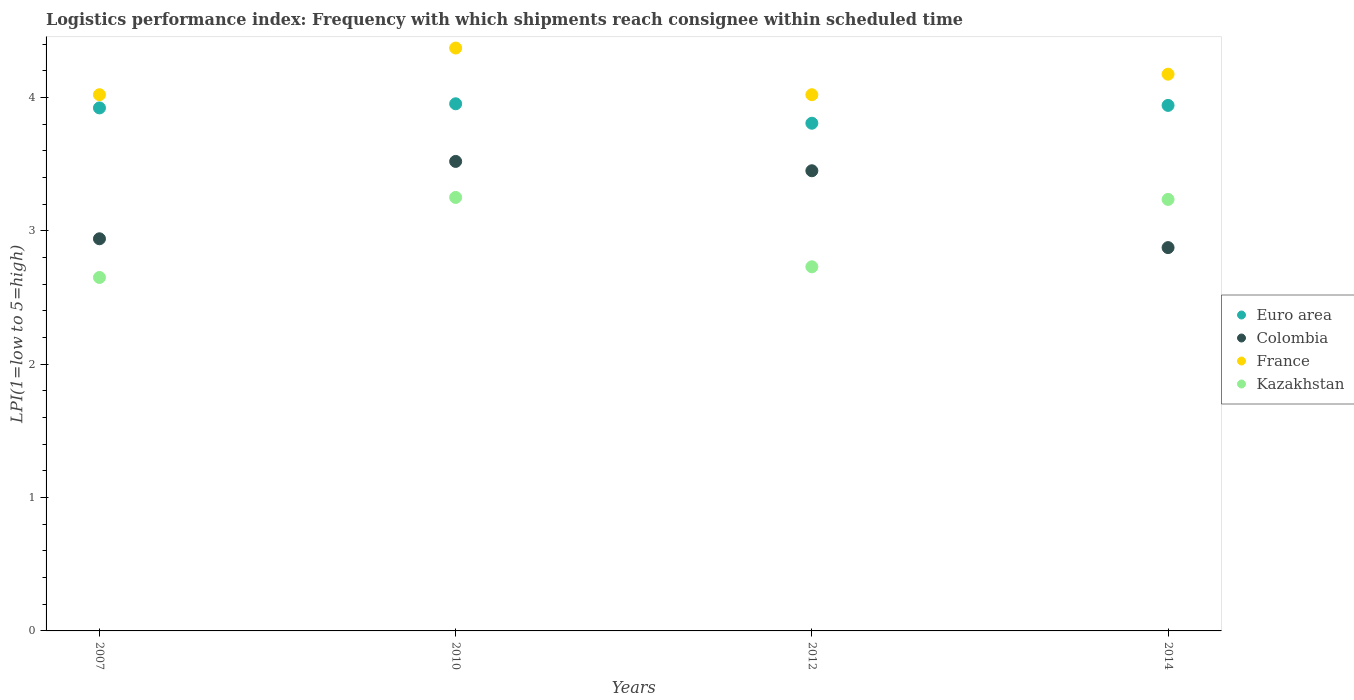What is the logistics performance index in Colombia in 2012?
Provide a short and direct response. 3.45. Across all years, what is the maximum logistics performance index in France?
Your response must be concise. 4.37. Across all years, what is the minimum logistics performance index in Kazakhstan?
Your response must be concise. 2.65. In which year was the logistics performance index in Euro area minimum?
Your answer should be compact. 2012. What is the total logistics performance index in France in the graph?
Keep it short and to the point. 16.58. What is the difference between the logistics performance index in Colombia in 2010 and that in 2014?
Keep it short and to the point. 0.65. What is the difference between the logistics performance index in Colombia in 2012 and the logistics performance index in Kazakhstan in 2010?
Your answer should be very brief. 0.2. What is the average logistics performance index in Euro area per year?
Offer a terse response. 3.9. In the year 2014, what is the difference between the logistics performance index in France and logistics performance index in Kazakhstan?
Provide a short and direct response. 0.94. In how many years, is the logistics performance index in Kazakhstan greater than 1.8?
Provide a short and direct response. 4. What is the ratio of the logistics performance index in Kazakhstan in 2007 to that in 2014?
Ensure brevity in your answer.  0.82. Is the logistics performance index in Colombia in 2012 less than that in 2014?
Keep it short and to the point. No. What is the difference between the highest and the second highest logistics performance index in Colombia?
Provide a short and direct response. 0.07. What is the difference between the highest and the lowest logistics performance index in France?
Offer a very short reply. 0.35. In how many years, is the logistics performance index in Colombia greater than the average logistics performance index in Colombia taken over all years?
Offer a terse response. 2. Is it the case that in every year, the sum of the logistics performance index in Euro area and logistics performance index in Kazakhstan  is greater than the sum of logistics performance index in France and logistics performance index in Colombia?
Provide a succinct answer. Yes. Is it the case that in every year, the sum of the logistics performance index in Kazakhstan and logistics performance index in France  is greater than the logistics performance index in Euro area?
Provide a succinct answer. Yes. Does the logistics performance index in Colombia monotonically increase over the years?
Provide a short and direct response. No. Is the logistics performance index in France strictly greater than the logistics performance index in Euro area over the years?
Give a very brief answer. Yes. Is the logistics performance index in Colombia strictly less than the logistics performance index in France over the years?
Offer a very short reply. Yes. How many dotlines are there?
Give a very brief answer. 4. What is the difference between two consecutive major ticks on the Y-axis?
Your answer should be very brief. 1. Does the graph contain grids?
Offer a terse response. No. What is the title of the graph?
Make the answer very short. Logistics performance index: Frequency with which shipments reach consignee within scheduled time. What is the label or title of the X-axis?
Your answer should be compact. Years. What is the label or title of the Y-axis?
Offer a very short reply. LPI(1=low to 5=high). What is the LPI(1=low to 5=high) of Euro area in 2007?
Your answer should be very brief. 3.92. What is the LPI(1=low to 5=high) in Colombia in 2007?
Provide a succinct answer. 2.94. What is the LPI(1=low to 5=high) in France in 2007?
Provide a short and direct response. 4.02. What is the LPI(1=low to 5=high) of Kazakhstan in 2007?
Your answer should be very brief. 2.65. What is the LPI(1=low to 5=high) of Euro area in 2010?
Provide a short and direct response. 3.95. What is the LPI(1=low to 5=high) of Colombia in 2010?
Your response must be concise. 3.52. What is the LPI(1=low to 5=high) of France in 2010?
Your response must be concise. 4.37. What is the LPI(1=low to 5=high) of Euro area in 2012?
Provide a succinct answer. 3.81. What is the LPI(1=low to 5=high) of Colombia in 2012?
Ensure brevity in your answer.  3.45. What is the LPI(1=low to 5=high) in France in 2012?
Your answer should be very brief. 4.02. What is the LPI(1=low to 5=high) of Kazakhstan in 2012?
Make the answer very short. 2.73. What is the LPI(1=low to 5=high) in Euro area in 2014?
Ensure brevity in your answer.  3.94. What is the LPI(1=low to 5=high) in Colombia in 2014?
Give a very brief answer. 2.87. What is the LPI(1=low to 5=high) in France in 2014?
Your answer should be very brief. 4.17. What is the LPI(1=low to 5=high) of Kazakhstan in 2014?
Your answer should be very brief. 3.24. Across all years, what is the maximum LPI(1=low to 5=high) in Euro area?
Keep it short and to the point. 3.95. Across all years, what is the maximum LPI(1=low to 5=high) in Colombia?
Ensure brevity in your answer.  3.52. Across all years, what is the maximum LPI(1=low to 5=high) of France?
Provide a short and direct response. 4.37. Across all years, what is the minimum LPI(1=low to 5=high) in Euro area?
Provide a short and direct response. 3.81. Across all years, what is the minimum LPI(1=low to 5=high) in Colombia?
Offer a very short reply. 2.87. Across all years, what is the minimum LPI(1=low to 5=high) of France?
Keep it short and to the point. 4.02. Across all years, what is the minimum LPI(1=low to 5=high) in Kazakhstan?
Give a very brief answer. 2.65. What is the total LPI(1=low to 5=high) of Euro area in the graph?
Keep it short and to the point. 15.62. What is the total LPI(1=low to 5=high) of Colombia in the graph?
Your answer should be compact. 12.78. What is the total LPI(1=low to 5=high) of France in the graph?
Give a very brief answer. 16.58. What is the total LPI(1=low to 5=high) of Kazakhstan in the graph?
Offer a very short reply. 11.87. What is the difference between the LPI(1=low to 5=high) of Euro area in 2007 and that in 2010?
Make the answer very short. -0.03. What is the difference between the LPI(1=low to 5=high) of Colombia in 2007 and that in 2010?
Offer a very short reply. -0.58. What is the difference between the LPI(1=low to 5=high) in France in 2007 and that in 2010?
Your answer should be very brief. -0.35. What is the difference between the LPI(1=low to 5=high) of Kazakhstan in 2007 and that in 2010?
Your response must be concise. -0.6. What is the difference between the LPI(1=low to 5=high) of Euro area in 2007 and that in 2012?
Your response must be concise. 0.11. What is the difference between the LPI(1=low to 5=high) of Colombia in 2007 and that in 2012?
Ensure brevity in your answer.  -0.51. What is the difference between the LPI(1=low to 5=high) in Kazakhstan in 2007 and that in 2012?
Ensure brevity in your answer.  -0.08. What is the difference between the LPI(1=low to 5=high) in Euro area in 2007 and that in 2014?
Your answer should be compact. -0.02. What is the difference between the LPI(1=low to 5=high) of Colombia in 2007 and that in 2014?
Provide a succinct answer. 0.07. What is the difference between the LPI(1=low to 5=high) in France in 2007 and that in 2014?
Your answer should be very brief. -0.15. What is the difference between the LPI(1=low to 5=high) of Kazakhstan in 2007 and that in 2014?
Your answer should be very brief. -0.59. What is the difference between the LPI(1=low to 5=high) of Euro area in 2010 and that in 2012?
Offer a terse response. 0.15. What is the difference between the LPI(1=low to 5=high) of Colombia in 2010 and that in 2012?
Provide a succinct answer. 0.07. What is the difference between the LPI(1=low to 5=high) in France in 2010 and that in 2012?
Give a very brief answer. 0.35. What is the difference between the LPI(1=low to 5=high) in Kazakhstan in 2010 and that in 2012?
Your answer should be very brief. 0.52. What is the difference between the LPI(1=low to 5=high) of Euro area in 2010 and that in 2014?
Offer a very short reply. 0.01. What is the difference between the LPI(1=low to 5=high) in Colombia in 2010 and that in 2014?
Your answer should be very brief. 0.65. What is the difference between the LPI(1=low to 5=high) in France in 2010 and that in 2014?
Give a very brief answer. 0.2. What is the difference between the LPI(1=low to 5=high) of Kazakhstan in 2010 and that in 2014?
Your answer should be very brief. 0.01. What is the difference between the LPI(1=low to 5=high) of Euro area in 2012 and that in 2014?
Ensure brevity in your answer.  -0.13. What is the difference between the LPI(1=low to 5=high) in Colombia in 2012 and that in 2014?
Keep it short and to the point. 0.58. What is the difference between the LPI(1=low to 5=high) of France in 2012 and that in 2014?
Provide a short and direct response. -0.15. What is the difference between the LPI(1=low to 5=high) in Kazakhstan in 2012 and that in 2014?
Offer a terse response. -0.51. What is the difference between the LPI(1=low to 5=high) in Euro area in 2007 and the LPI(1=low to 5=high) in Colombia in 2010?
Offer a terse response. 0.4. What is the difference between the LPI(1=low to 5=high) of Euro area in 2007 and the LPI(1=low to 5=high) of France in 2010?
Offer a very short reply. -0.45. What is the difference between the LPI(1=low to 5=high) in Euro area in 2007 and the LPI(1=low to 5=high) in Kazakhstan in 2010?
Make the answer very short. 0.67. What is the difference between the LPI(1=low to 5=high) in Colombia in 2007 and the LPI(1=low to 5=high) in France in 2010?
Keep it short and to the point. -1.43. What is the difference between the LPI(1=low to 5=high) in Colombia in 2007 and the LPI(1=low to 5=high) in Kazakhstan in 2010?
Provide a succinct answer. -0.31. What is the difference between the LPI(1=low to 5=high) in France in 2007 and the LPI(1=low to 5=high) in Kazakhstan in 2010?
Your answer should be very brief. 0.77. What is the difference between the LPI(1=low to 5=high) in Euro area in 2007 and the LPI(1=low to 5=high) in Colombia in 2012?
Offer a very short reply. 0.47. What is the difference between the LPI(1=low to 5=high) of Euro area in 2007 and the LPI(1=low to 5=high) of France in 2012?
Ensure brevity in your answer.  -0.1. What is the difference between the LPI(1=low to 5=high) of Euro area in 2007 and the LPI(1=low to 5=high) of Kazakhstan in 2012?
Ensure brevity in your answer.  1.19. What is the difference between the LPI(1=low to 5=high) in Colombia in 2007 and the LPI(1=low to 5=high) in France in 2012?
Your answer should be very brief. -1.08. What is the difference between the LPI(1=low to 5=high) in Colombia in 2007 and the LPI(1=low to 5=high) in Kazakhstan in 2012?
Your answer should be compact. 0.21. What is the difference between the LPI(1=low to 5=high) of France in 2007 and the LPI(1=low to 5=high) of Kazakhstan in 2012?
Your response must be concise. 1.29. What is the difference between the LPI(1=low to 5=high) in Euro area in 2007 and the LPI(1=low to 5=high) in Colombia in 2014?
Your answer should be very brief. 1.05. What is the difference between the LPI(1=low to 5=high) in Euro area in 2007 and the LPI(1=low to 5=high) in France in 2014?
Your response must be concise. -0.25. What is the difference between the LPI(1=low to 5=high) in Euro area in 2007 and the LPI(1=low to 5=high) in Kazakhstan in 2014?
Ensure brevity in your answer.  0.69. What is the difference between the LPI(1=low to 5=high) of Colombia in 2007 and the LPI(1=low to 5=high) of France in 2014?
Your answer should be compact. -1.23. What is the difference between the LPI(1=low to 5=high) of Colombia in 2007 and the LPI(1=low to 5=high) of Kazakhstan in 2014?
Your answer should be very brief. -0.3. What is the difference between the LPI(1=low to 5=high) in France in 2007 and the LPI(1=low to 5=high) in Kazakhstan in 2014?
Make the answer very short. 0.78. What is the difference between the LPI(1=low to 5=high) in Euro area in 2010 and the LPI(1=low to 5=high) in Colombia in 2012?
Ensure brevity in your answer.  0.5. What is the difference between the LPI(1=low to 5=high) in Euro area in 2010 and the LPI(1=low to 5=high) in France in 2012?
Your answer should be very brief. -0.07. What is the difference between the LPI(1=low to 5=high) of Euro area in 2010 and the LPI(1=low to 5=high) of Kazakhstan in 2012?
Your answer should be very brief. 1.22. What is the difference between the LPI(1=low to 5=high) in Colombia in 2010 and the LPI(1=low to 5=high) in France in 2012?
Give a very brief answer. -0.5. What is the difference between the LPI(1=low to 5=high) in Colombia in 2010 and the LPI(1=low to 5=high) in Kazakhstan in 2012?
Offer a very short reply. 0.79. What is the difference between the LPI(1=low to 5=high) in France in 2010 and the LPI(1=low to 5=high) in Kazakhstan in 2012?
Your answer should be very brief. 1.64. What is the difference between the LPI(1=low to 5=high) of Euro area in 2010 and the LPI(1=low to 5=high) of Colombia in 2014?
Offer a terse response. 1.08. What is the difference between the LPI(1=low to 5=high) in Euro area in 2010 and the LPI(1=low to 5=high) in France in 2014?
Make the answer very short. -0.22. What is the difference between the LPI(1=low to 5=high) in Euro area in 2010 and the LPI(1=low to 5=high) in Kazakhstan in 2014?
Make the answer very short. 0.72. What is the difference between the LPI(1=low to 5=high) in Colombia in 2010 and the LPI(1=low to 5=high) in France in 2014?
Provide a succinct answer. -0.65. What is the difference between the LPI(1=low to 5=high) in Colombia in 2010 and the LPI(1=low to 5=high) in Kazakhstan in 2014?
Your response must be concise. 0.28. What is the difference between the LPI(1=low to 5=high) of France in 2010 and the LPI(1=low to 5=high) of Kazakhstan in 2014?
Keep it short and to the point. 1.13. What is the difference between the LPI(1=low to 5=high) of Euro area in 2012 and the LPI(1=low to 5=high) of Colombia in 2014?
Your answer should be compact. 0.93. What is the difference between the LPI(1=low to 5=high) in Euro area in 2012 and the LPI(1=low to 5=high) in France in 2014?
Your answer should be very brief. -0.37. What is the difference between the LPI(1=low to 5=high) in Euro area in 2012 and the LPI(1=low to 5=high) in Kazakhstan in 2014?
Make the answer very short. 0.57. What is the difference between the LPI(1=low to 5=high) of Colombia in 2012 and the LPI(1=low to 5=high) of France in 2014?
Keep it short and to the point. -0.72. What is the difference between the LPI(1=low to 5=high) in Colombia in 2012 and the LPI(1=low to 5=high) in Kazakhstan in 2014?
Ensure brevity in your answer.  0.21. What is the difference between the LPI(1=low to 5=high) of France in 2012 and the LPI(1=low to 5=high) of Kazakhstan in 2014?
Offer a very short reply. 0.78. What is the average LPI(1=low to 5=high) in Euro area per year?
Ensure brevity in your answer.  3.9. What is the average LPI(1=low to 5=high) in Colombia per year?
Give a very brief answer. 3.2. What is the average LPI(1=low to 5=high) of France per year?
Your response must be concise. 4.15. What is the average LPI(1=low to 5=high) in Kazakhstan per year?
Provide a short and direct response. 2.97. In the year 2007, what is the difference between the LPI(1=low to 5=high) in Euro area and LPI(1=low to 5=high) in Colombia?
Keep it short and to the point. 0.98. In the year 2007, what is the difference between the LPI(1=low to 5=high) in Euro area and LPI(1=low to 5=high) in France?
Offer a terse response. -0.1. In the year 2007, what is the difference between the LPI(1=low to 5=high) in Euro area and LPI(1=low to 5=high) in Kazakhstan?
Your response must be concise. 1.27. In the year 2007, what is the difference between the LPI(1=low to 5=high) in Colombia and LPI(1=low to 5=high) in France?
Make the answer very short. -1.08. In the year 2007, what is the difference between the LPI(1=low to 5=high) of Colombia and LPI(1=low to 5=high) of Kazakhstan?
Offer a very short reply. 0.29. In the year 2007, what is the difference between the LPI(1=low to 5=high) in France and LPI(1=low to 5=high) in Kazakhstan?
Ensure brevity in your answer.  1.37. In the year 2010, what is the difference between the LPI(1=low to 5=high) in Euro area and LPI(1=low to 5=high) in Colombia?
Keep it short and to the point. 0.43. In the year 2010, what is the difference between the LPI(1=low to 5=high) in Euro area and LPI(1=low to 5=high) in France?
Provide a succinct answer. -0.42. In the year 2010, what is the difference between the LPI(1=low to 5=high) in Euro area and LPI(1=low to 5=high) in Kazakhstan?
Ensure brevity in your answer.  0.7. In the year 2010, what is the difference between the LPI(1=low to 5=high) in Colombia and LPI(1=low to 5=high) in France?
Give a very brief answer. -0.85. In the year 2010, what is the difference between the LPI(1=low to 5=high) in Colombia and LPI(1=low to 5=high) in Kazakhstan?
Your response must be concise. 0.27. In the year 2010, what is the difference between the LPI(1=low to 5=high) in France and LPI(1=low to 5=high) in Kazakhstan?
Offer a terse response. 1.12. In the year 2012, what is the difference between the LPI(1=low to 5=high) of Euro area and LPI(1=low to 5=high) of Colombia?
Provide a short and direct response. 0.36. In the year 2012, what is the difference between the LPI(1=low to 5=high) of Euro area and LPI(1=low to 5=high) of France?
Your response must be concise. -0.21. In the year 2012, what is the difference between the LPI(1=low to 5=high) in Euro area and LPI(1=low to 5=high) in Kazakhstan?
Offer a very short reply. 1.08. In the year 2012, what is the difference between the LPI(1=low to 5=high) of Colombia and LPI(1=low to 5=high) of France?
Your answer should be very brief. -0.57. In the year 2012, what is the difference between the LPI(1=low to 5=high) in Colombia and LPI(1=low to 5=high) in Kazakhstan?
Your answer should be very brief. 0.72. In the year 2012, what is the difference between the LPI(1=low to 5=high) of France and LPI(1=low to 5=high) of Kazakhstan?
Offer a very short reply. 1.29. In the year 2014, what is the difference between the LPI(1=low to 5=high) of Euro area and LPI(1=low to 5=high) of Colombia?
Give a very brief answer. 1.07. In the year 2014, what is the difference between the LPI(1=low to 5=high) of Euro area and LPI(1=low to 5=high) of France?
Offer a terse response. -0.23. In the year 2014, what is the difference between the LPI(1=low to 5=high) in Euro area and LPI(1=low to 5=high) in Kazakhstan?
Provide a short and direct response. 0.7. In the year 2014, what is the difference between the LPI(1=low to 5=high) of Colombia and LPI(1=low to 5=high) of France?
Ensure brevity in your answer.  -1.3. In the year 2014, what is the difference between the LPI(1=low to 5=high) in Colombia and LPI(1=low to 5=high) in Kazakhstan?
Give a very brief answer. -0.36. In the year 2014, what is the difference between the LPI(1=low to 5=high) of France and LPI(1=low to 5=high) of Kazakhstan?
Ensure brevity in your answer.  0.94. What is the ratio of the LPI(1=low to 5=high) of Euro area in 2007 to that in 2010?
Offer a very short reply. 0.99. What is the ratio of the LPI(1=low to 5=high) of Colombia in 2007 to that in 2010?
Your answer should be very brief. 0.84. What is the ratio of the LPI(1=low to 5=high) in France in 2007 to that in 2010?
Your response must be concise. 0.92. What is the ratio of the LPI(1=low to 5=high) of Kazakhstan in 2007 to that in 2010?
Make the answer very short. 0.82. What is the ratio of the LPI(1=low to 5=high) in Euro area in 2007 to that in 2012?
Offer a terse response. 1.03. What is the ratio of the LPI(1=low to 5=high) of Colombia in 2007 to that in 2012?
Your response must be concise. 0.85. What is the ratio of the LPI(1=low to 5=high) of Kazakhstan in 2007 to that in 2012?
Ensure brevity in your answer.  0.97. What is the ratio of the LPI(1=low to 5=high) of Colombia in 2007 to that in 2014?
Offer a very short reply. 1.02. What is the ratio of the LPI(1=low to 5=high) in France in 2007 to that in 2014?
Provide a succinct answer. 0.96. What is the ratio of the LPI(1=low to 5=high) in Kazakhstan in 2007 to that in 2014?
Provide a short and direct response. 0.82. What is the ratio of the LPI(1=low to 5=high) in Euro area in 2010 to that in 2012?
Your answer should be very brief. 1.04. What is the ratio of the LPI(1=low to 5=high) in Colombia in 2010 to that in 2012?
Provide a succinct answer. 1.02. What is the ratio of the LPI(1=low to 5=high) in France in 2010 to that in 2012?
Keep it short and to the point. 1.09. What is the ratio of the LPI(1=low to 5=high) in Kazakhstan in 2010 to that in 2012?
Your answer should be compact. 1.19. What is the ratio of the LPI(1=low to 5=high) of Colombia in 2010 to that in 2014?
Make the answer very short. 1.22. What is the ratio of the LPI(1=low to 5=high) of France in 2010 to that in 2014?
Your answer should be compact. 1.05. What is the ratio of the LPI(1=low to 5=high) in Euro area in 2012 to that in 2014?
Your answer should be compact. 0.97. What is the ratio of the LPI(1=low to 5=high) in Colombia in 2012 to that in 2014?
Your response must be concise. 1.2. What is the ratio of the LPI(1=low to 5=high) of France in 2012 to that in 2014?
Keep it short and to the point. 0.96. What is the ratio of the LPI(1=low to 5=high) in Kazakhstan in 2012 to that in 2014?
Provide a short and direct response. 0.84. What is the difference between the highest and the second highest LPI(1=low to 5=high) of Euro area?
Make the answer very short. 0.01. What is the difference between the highest and the second highest LPI(1=low to 5=high) of Colombia?
Your response must be concise. 0.07. What is the difference between the highest and the second highest LPI(1=low to 5=high) in France?
Keep it short and to the point. 0.2. What is the difference between the highest and the second highest LPI(1=low to 5=high) of Kazakhstan?
Offer a terse response. 0.01. What is the difference between the highest and the lowest LPI(1=low to 5=high) of Euro area?
Keep it short and to the point. 0.15. What is the difference between the highest and the lowest LPI(1=low to 5=high) of Colombia?
Your answer should be very brief. 0.65. What is the difference between the highest and the lowest LPI(1=low to 5=high) in France?
Provide a succinct answer. 0.35. 